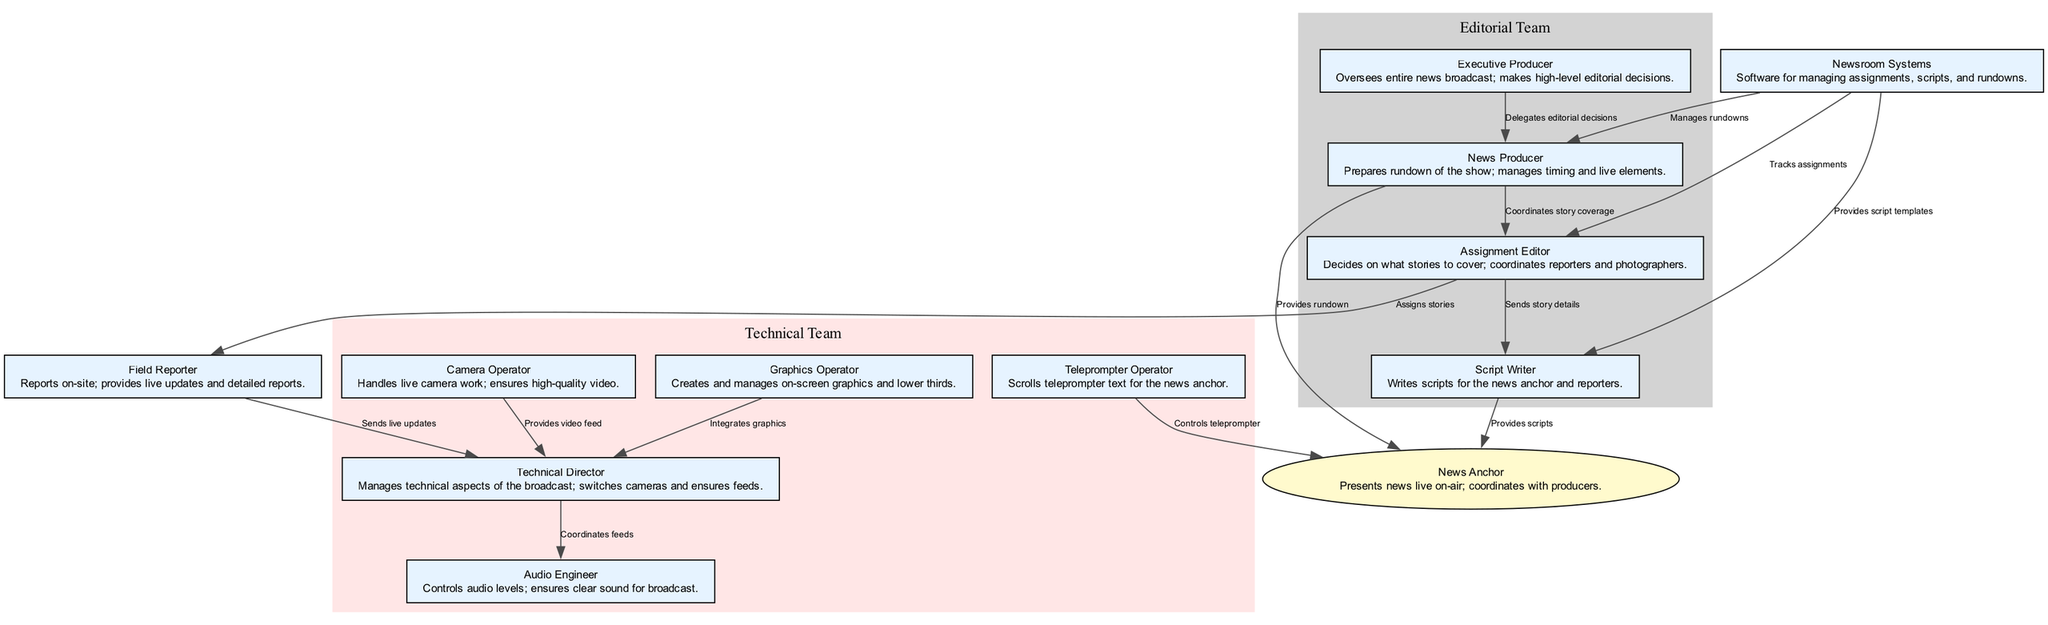What is the role of the news anchor? The news anchor presents news live on-air and coordinates with producers. This role is directly described within the node labeled "News Anchor."
Answer: Presents news live on-air; coordinates with producers How many nodes represent the technical team? The technical team nodes include the Technical Director, Camera Operator, Graphics Operator, Audio Engineer, and Teleprompter Operator. Counting these nodes gives a total of five.
Answer: Five Who provides scripts to the news anchor? The Script Writer is responsible for writing scripts that are provided to the news anchor. This relationship is indicated by the directed edge from the Script Writer to the News Anchor.
Answer: Script Writer What does the assignment editor do? The Assignment Editor decides on what stories to cover and coordinates reporters and photographers, which is explicitly defined in the node description.
Answer: Decides on what stories to cover; coordinates reporters and photographers Which teams are coordinated by the news producer? The news producer coordinates with the assignment editor for story coverage and provides rundowns to the news anchor. This means that both editorial and technical aspects intersect.
Answer: Editorial team and technical team How does the technical director interact with the audio engineer? The Technical Director coordinates feeds with the Audio Engineer, as indicated by the directed edge labeled "Coordinates feeds" between these two nodes. This shows a direct collaborative relationship.
Answer: Coordinates feeds What systems are utilized for managing scripts? The Newsroom Systems provide script templates to the Script Writer, which is specified with a directed edge from Newsroom Systems to Script Writer in the diagram.
Answer: Newsroom Systems List the flow of information from the assignment editor to the field reporter. The Assignment Editor assigns stories to the Field Reporter. This flow can be tracked by following the directed edge from Assignment Editor to Field Reporter.
Answer: Assigns stories What kind of decisions does the executive producer make? The Executive Producer makes high-level editorial decisions, which is directly stated in the node description. This describes the high-level oversight role of the executive producer.
Answer: High-level editorial decisions 